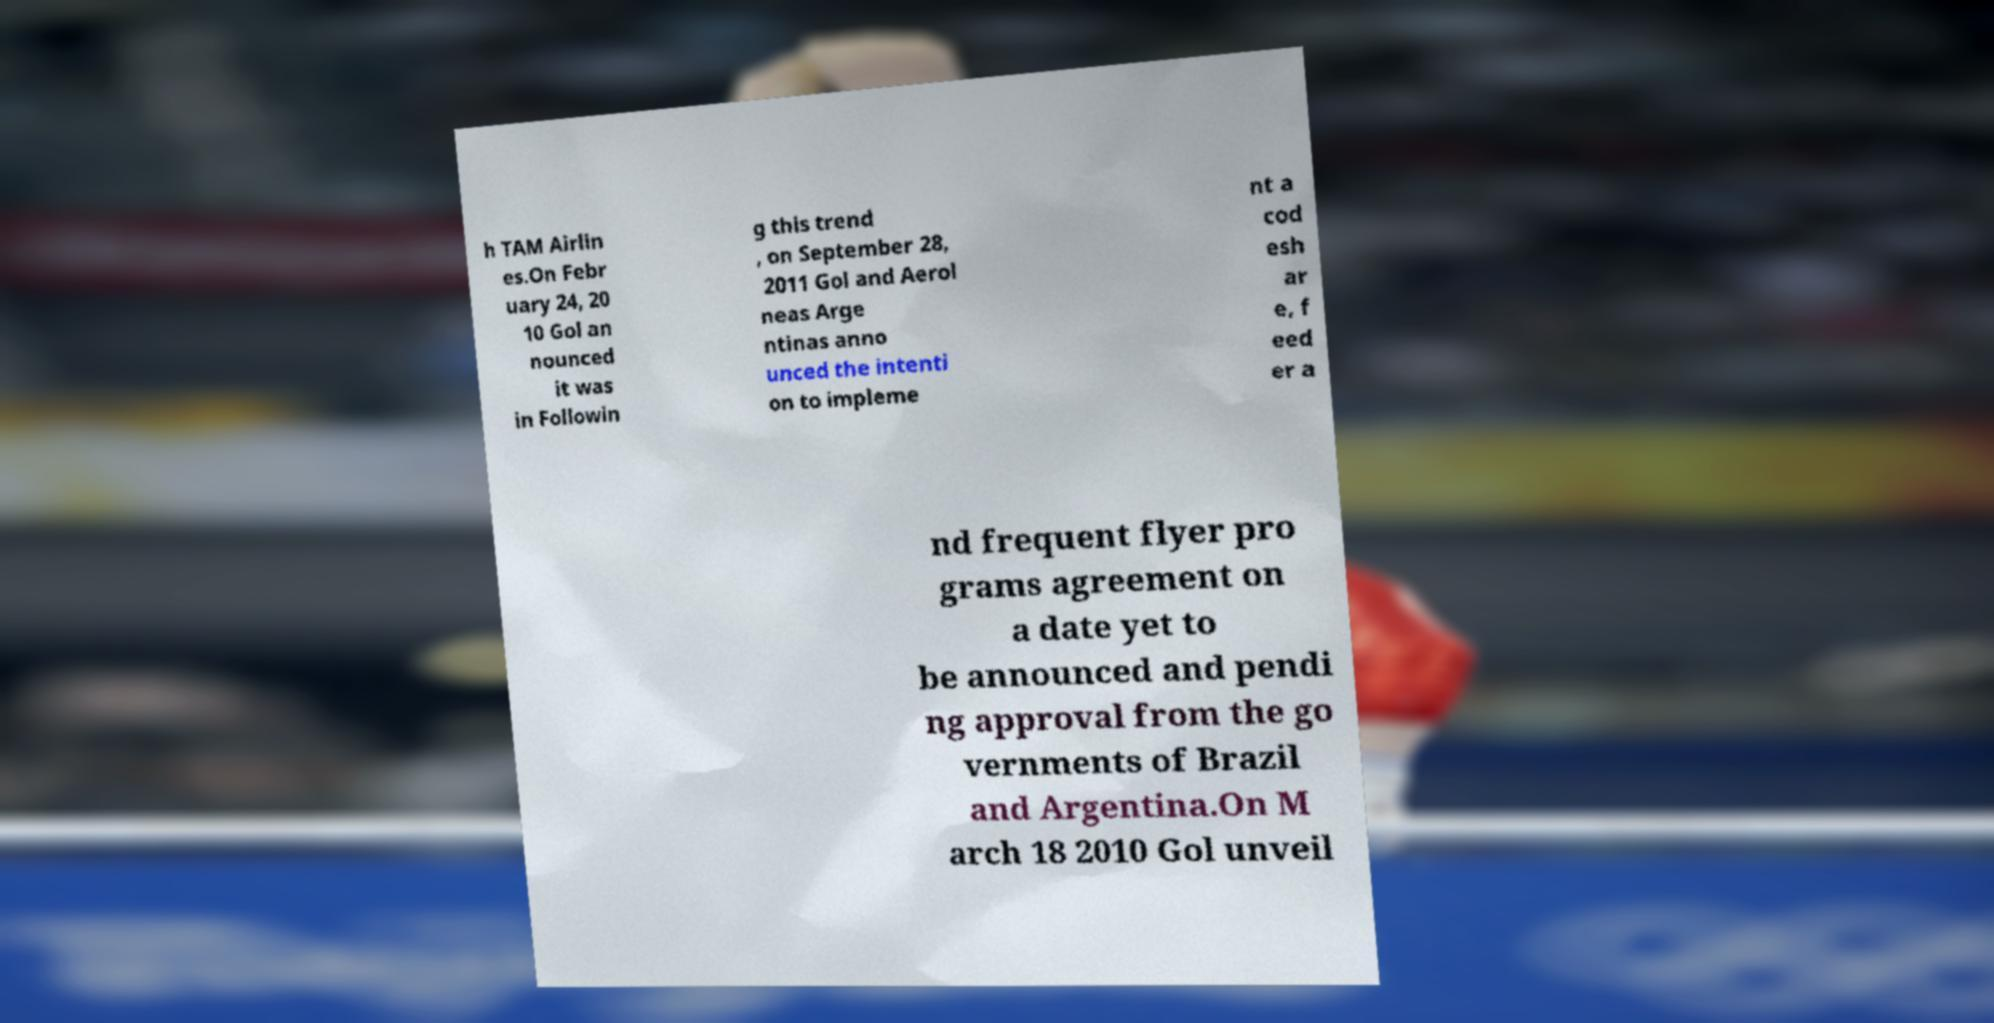Could you assist in decoding the text presented in this image and type it out clearly? h TAM Airlin es.On Febr uary 24, 20 10 Gol an nounced it was in Followin g this trend , on September 28, 2011 Gol and Aerol neas Arge ntinas anno unced the intenti on to impleme nt a cod esh ar e, f eed er a nd frequent flyer pro grams agreement on a date yet to be announced and pendi ng approval from the go vernments of Brazil and Argentina.On M arch 18 2010 Gol unveil 